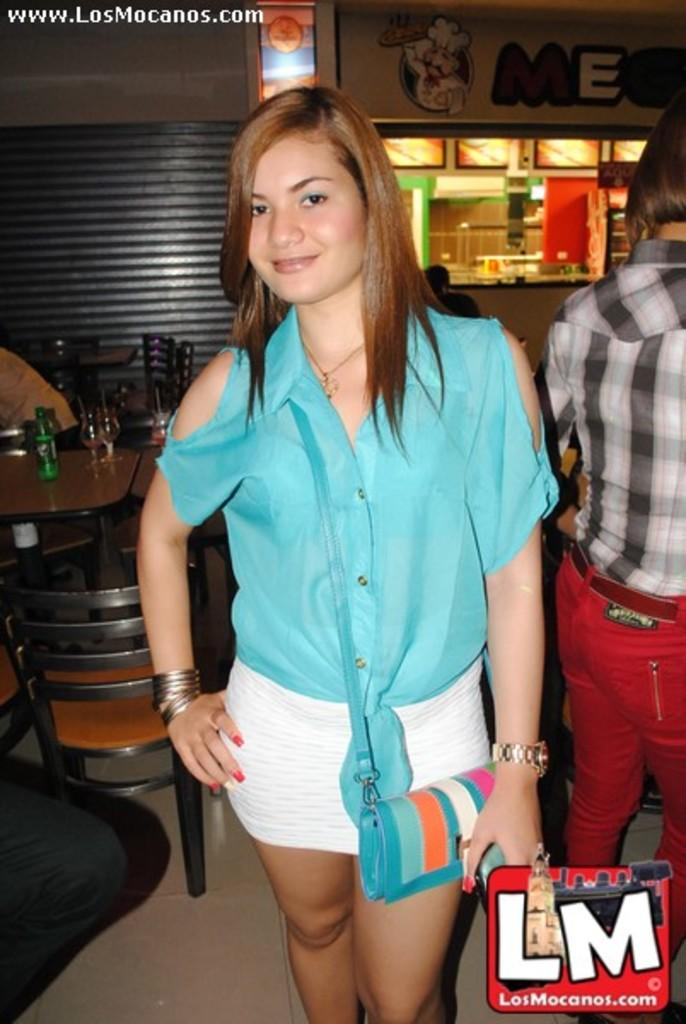What is the main subject of the image? There is a woman standing in the center of the image. What is the woman holding in the image? The woman is holding a handbag. What can be seen in the background of the image? There is a wall, a table, chairs, and a few persons in the background of the image. Can you tell me how many goats are visible in the image? There are no goats present in the image. What type of machine is being used by the woman in the image? There is no machine visible in the image; the woman is simply standing and holding a handbag. 